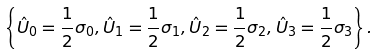<formula> <loc_0><loc_0><loc_500><loc_500>\left \{ \hat { U } _ { 0 } = \frac { 1 } { 2 } \sigma _ { 0 } , \hat { U } _ { 1 } = \frac { 1 } { 2 } \sigma _ { 1 } , \hat { U } _ { 2 } = \frac { 1 } { 2 } \sigma _ { 2 } , \hat { U } _ { 3 } = \frac { 1 } { 2 } \sigma _ { 3 } \right \} .</formula> 